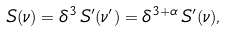Convert formula to latex. <formula><loc_0><loc_0><loc_500><loc_500>S ( \nu ) = \delta ^ { 3 } \, S ^ { \prime } ( \nu ^ { \prime } ) = \delta ^ { 3 + \alpha } \, S ^ { \prime } ( \nu ) ,</formula> 